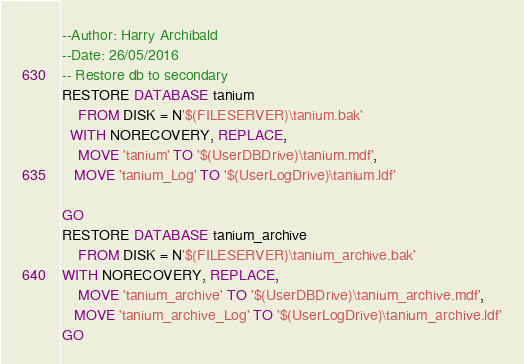Convert code to text. <code><loc_0><loc_0><loc_500><loc_500><_SQL_>--Author: Harry Archibald
--Date: 26/05/2016
-- Restore db to secondary
RESTORE DATABASE tanium
    FROM DISK = N'$(FILESERVER)\tanium.bak'
  WITH NORECOVERY, REPLACE,
    MOVE 'tanium' TO '$(UserDBDrive)\tanium.mdf', 
   MOVE 'tanium_Log' TO '$(UserLogDrive)\tanium.ldf'

GO
RESTORE DATABASE tanium_archive
    FROM DISK = N'$(FILESERVER)\tanium_archive.bak'
WITH NORECOVERY, REPLACE,
    MOVE 'tanium_archive' TO '$(UserDBDrive)\tanium_archive.mdf', 
   MOVE 'tanium_archive_Log' TO '$(UserLogDrive)\tanium_archive.ldf'
GO</code> 